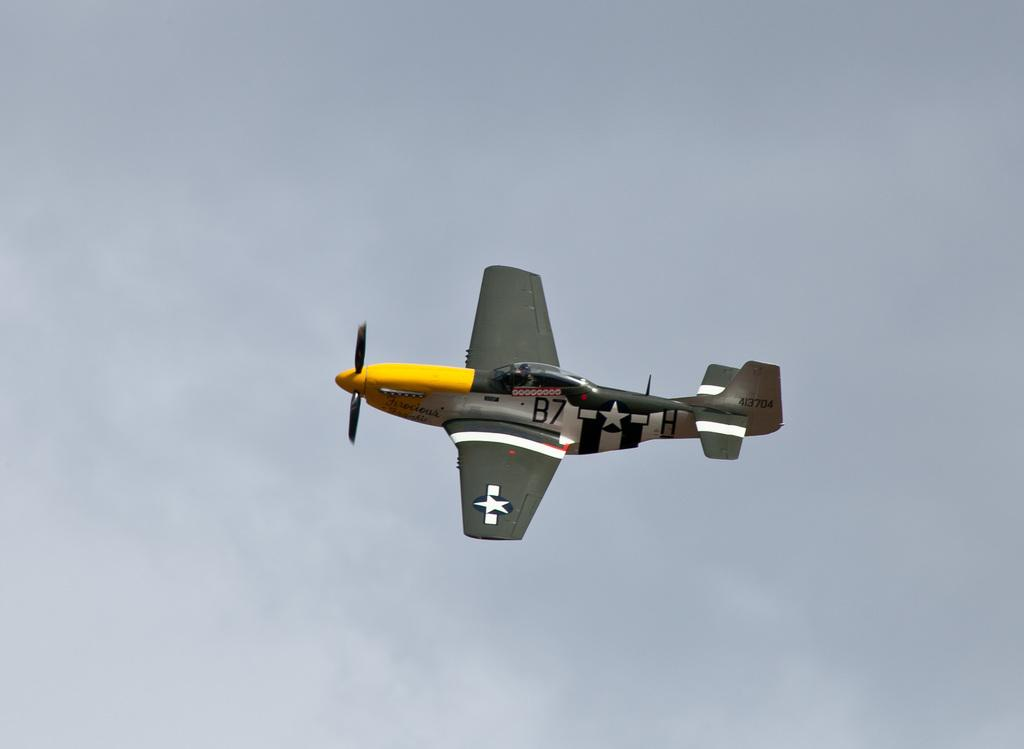<image>
Relay a brief, clear account of the picture shown. A yellow and gray plane says B7 on the side. 